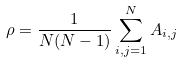Convert formula to latex. <formula><loc_0><loc_0><loc_500><loc_500>\rho = \frac { 1 } { N ( N - 1 ) } \sum _ { i , j = 1 } ^ { N } A _ { i , j }</formula> 